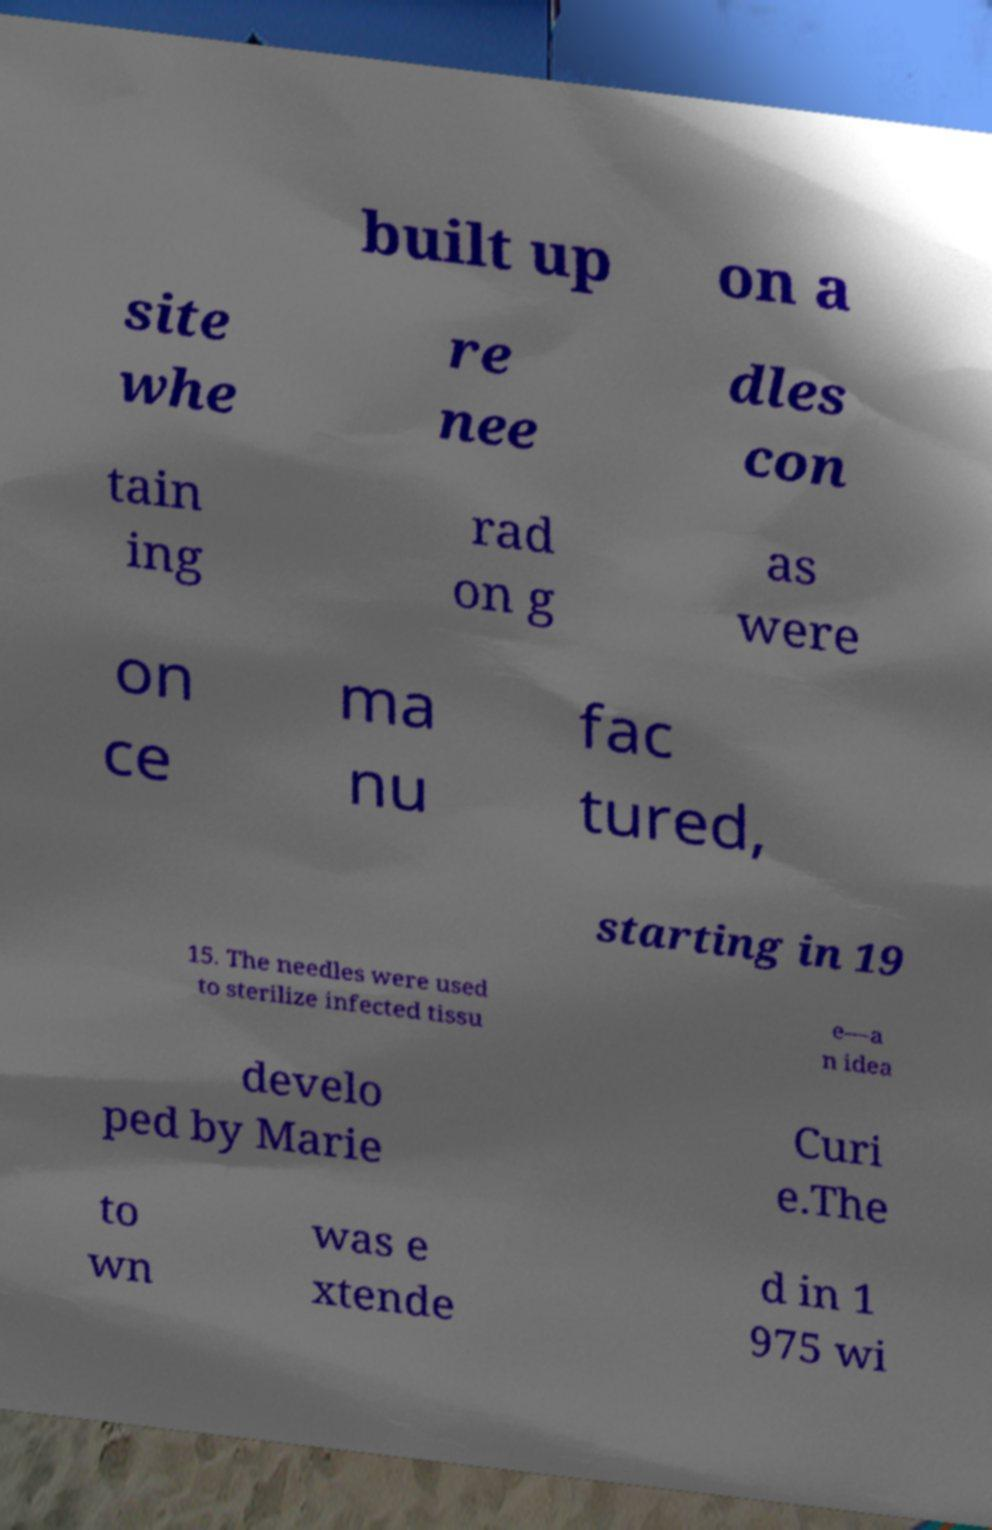Could you assist in decoding the text presented in this image and type it out clearly? built up on a site whe re nee dles con tain ing rad on g as were on ce ma nu fac tured, starting in 19 15. The needles were used to sterilize infected tissu e—a n idea develo ped by Marie Curi e.The to wn was e xtende d in 1 975 wi 